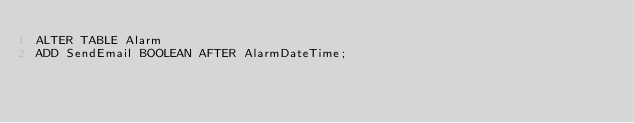<code> <loc_0><loc_0><loc_500><loc_500><_SQL_>ALTER TABLE Alarm 
ADD SendEmail BOOLEAN AFTER AlarmDateTime;
</code> 